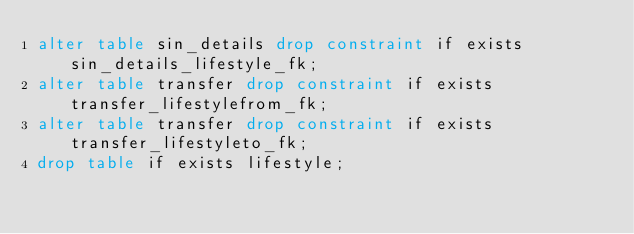Convert code to text. <code><loc_0><loc_0><loc_500><loc_500><_SQL_>alter table sin_details drop constraint if exists sin_details_lifestyle_fk;
alter table transfer drop constraint if exists transfer_lifestylefrom_fk;
alter table transfer drop constraint if exists transfer_lifestyleto_fk;
drop table if exists lifestyle;
</code> 